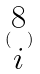Convert formula to latex. <formula><loc_0><loc_0><loc_500><loc_500>( \begin{matrix} 8 \\ i \end{matrix} )</formula> 